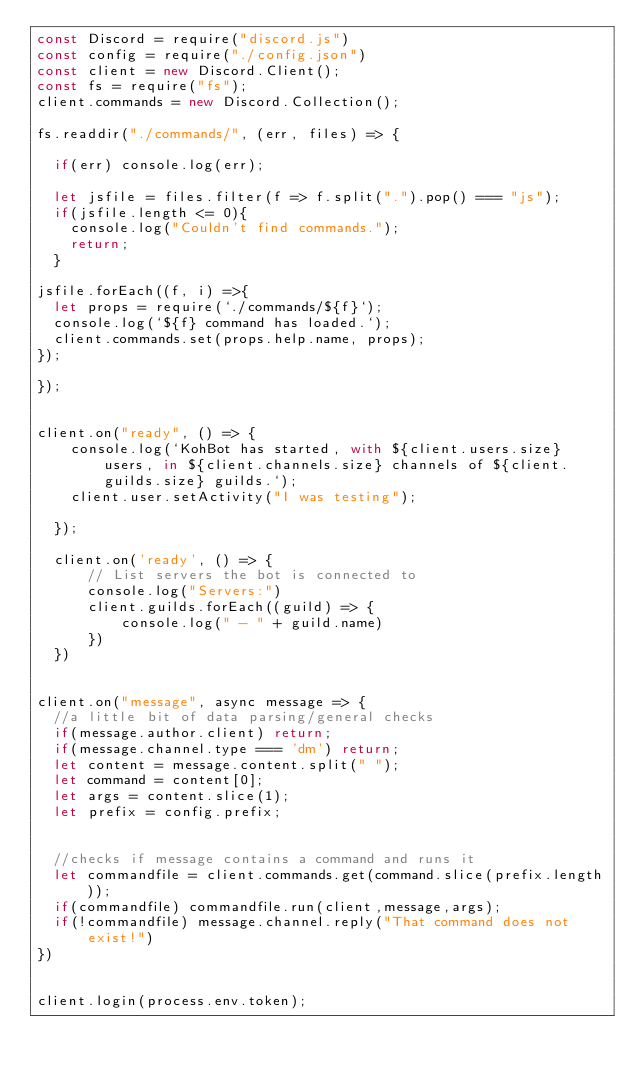<code> <loc_0><loc_0><loc_500><loc_500><_JavaScript_>const Discord = require("discord.js")
const config = require("./config.json")
const client = new Discord.Client();
const fs = require("fs");
client.commands = new Discord.Collection();

fs.readdir("./commands/", (err, files) => {

  if(err) console.log(err);

  let jsfile = files.filter(f => f.split(".").pop() === "js");
  if(jsfile.length <= 0){
    console.log("Couldn't find commands.");
    return;
  }

jsfile.forEach((f, i) =>{
  let props = require(`./commands/${f}`);
  console.log(`${f} command has loaded.`);
  client.commands.set(props.help.name, props);
});

});


client.on("ready", () => {
    console.log(`KohBot has started, with ${client.users.size} users, in ${client.channels.size} channels of ${client.guilds.size} guilds.`); 
    client.user.setActivity("I was testing");
  
  });
  
  client.on('ready', () => {
      // List servers the bot is connected to
      console.log("Servers:")
      client.guilds.forEach((guild) => {
          console.log(" - " + guild.name)
      })
  })
   

client.on("message", async message => {
  //a little bit of data parsing/general checks
  if(message.author.client) return;
  if(message.channel.type === 'dm') return;
  let content = message.content.split(" ");
  let command = content[0];
  let args = content.slice(1);
  let prefix = config.prefix;


  //checks if message contains a command and runs it
  let commandfile = client.commands.get(command.slice(prefix.length));
  if(commandfile) commandfile.run(client,message,args);
  if(!commandfile) message.channel.reply("That command does not exist!")
})


client.login(process.env.token);</code> 